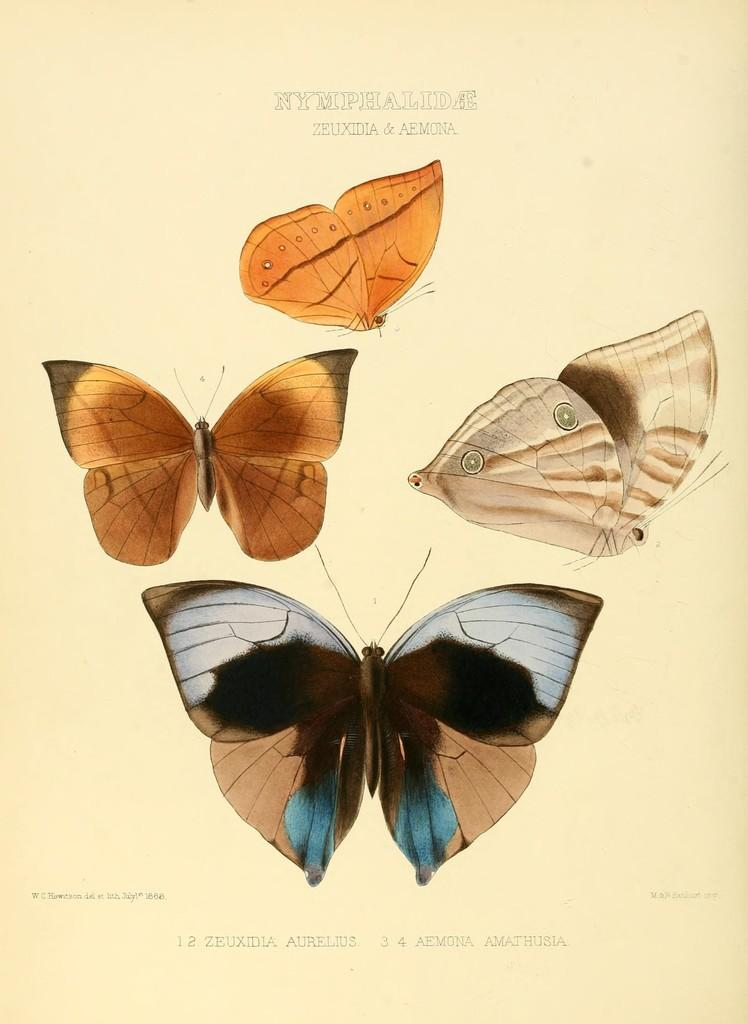What type of animals can be seen in the image? There are butterflies in the image. What is written at the top of the image? There is text at the top of the image. What is written at the bottom of the image? There is text at the bottom of the image. What type of peace symbol can be seen in the image? There is no peace symbol present in the image; it features butterflies and text. What question is being asked in the image? There is no question present in the image; it only contains text and butterflies. 